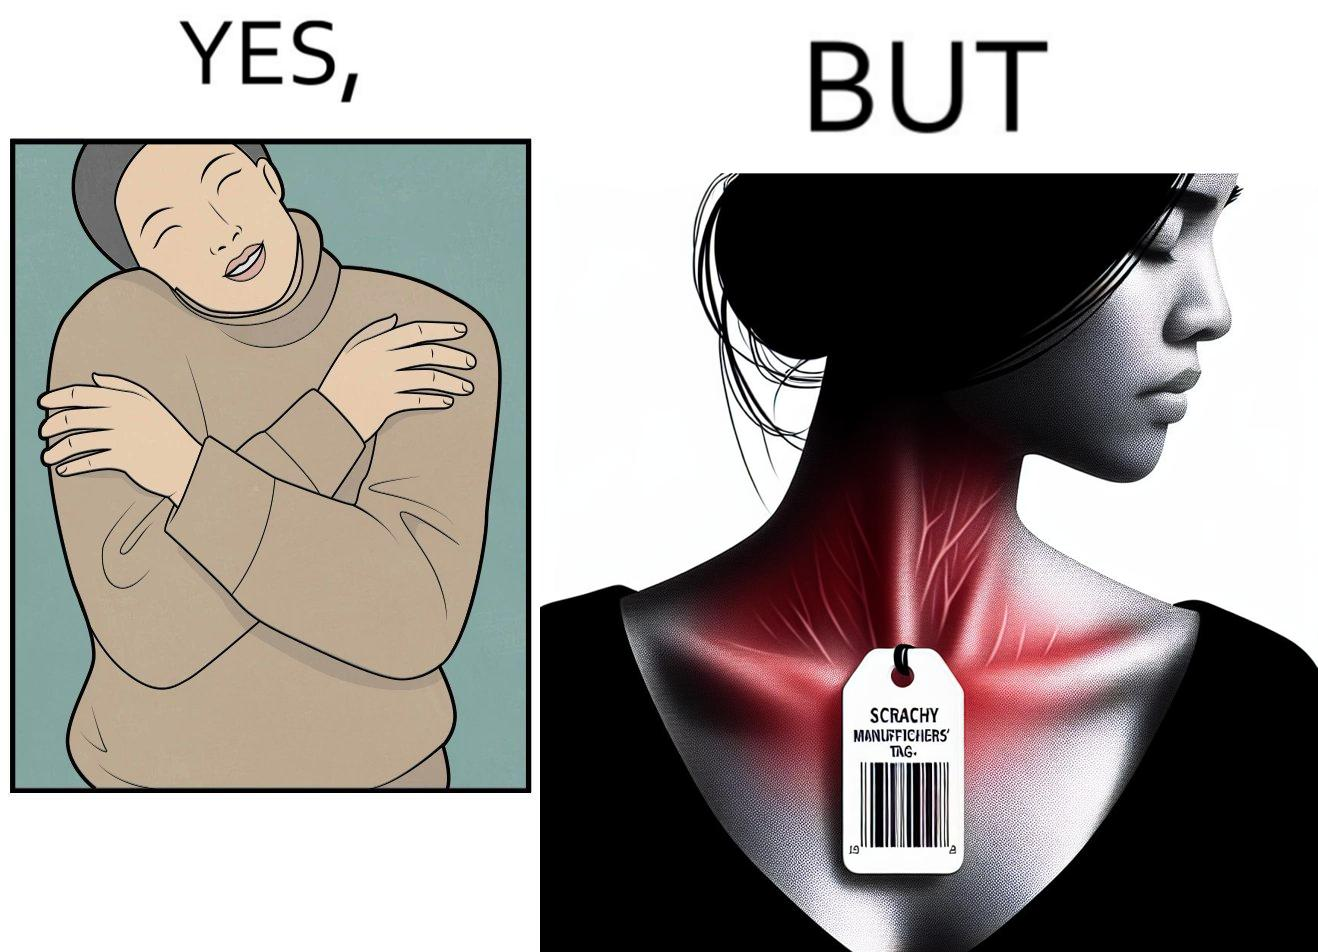Describe the satirical element in this image. The images are funny since it shows how even though sweaters and other clothings provide much comfort, a tiny manufacturers tag ends up causing the user a lot of discomfort due to constant scratching 